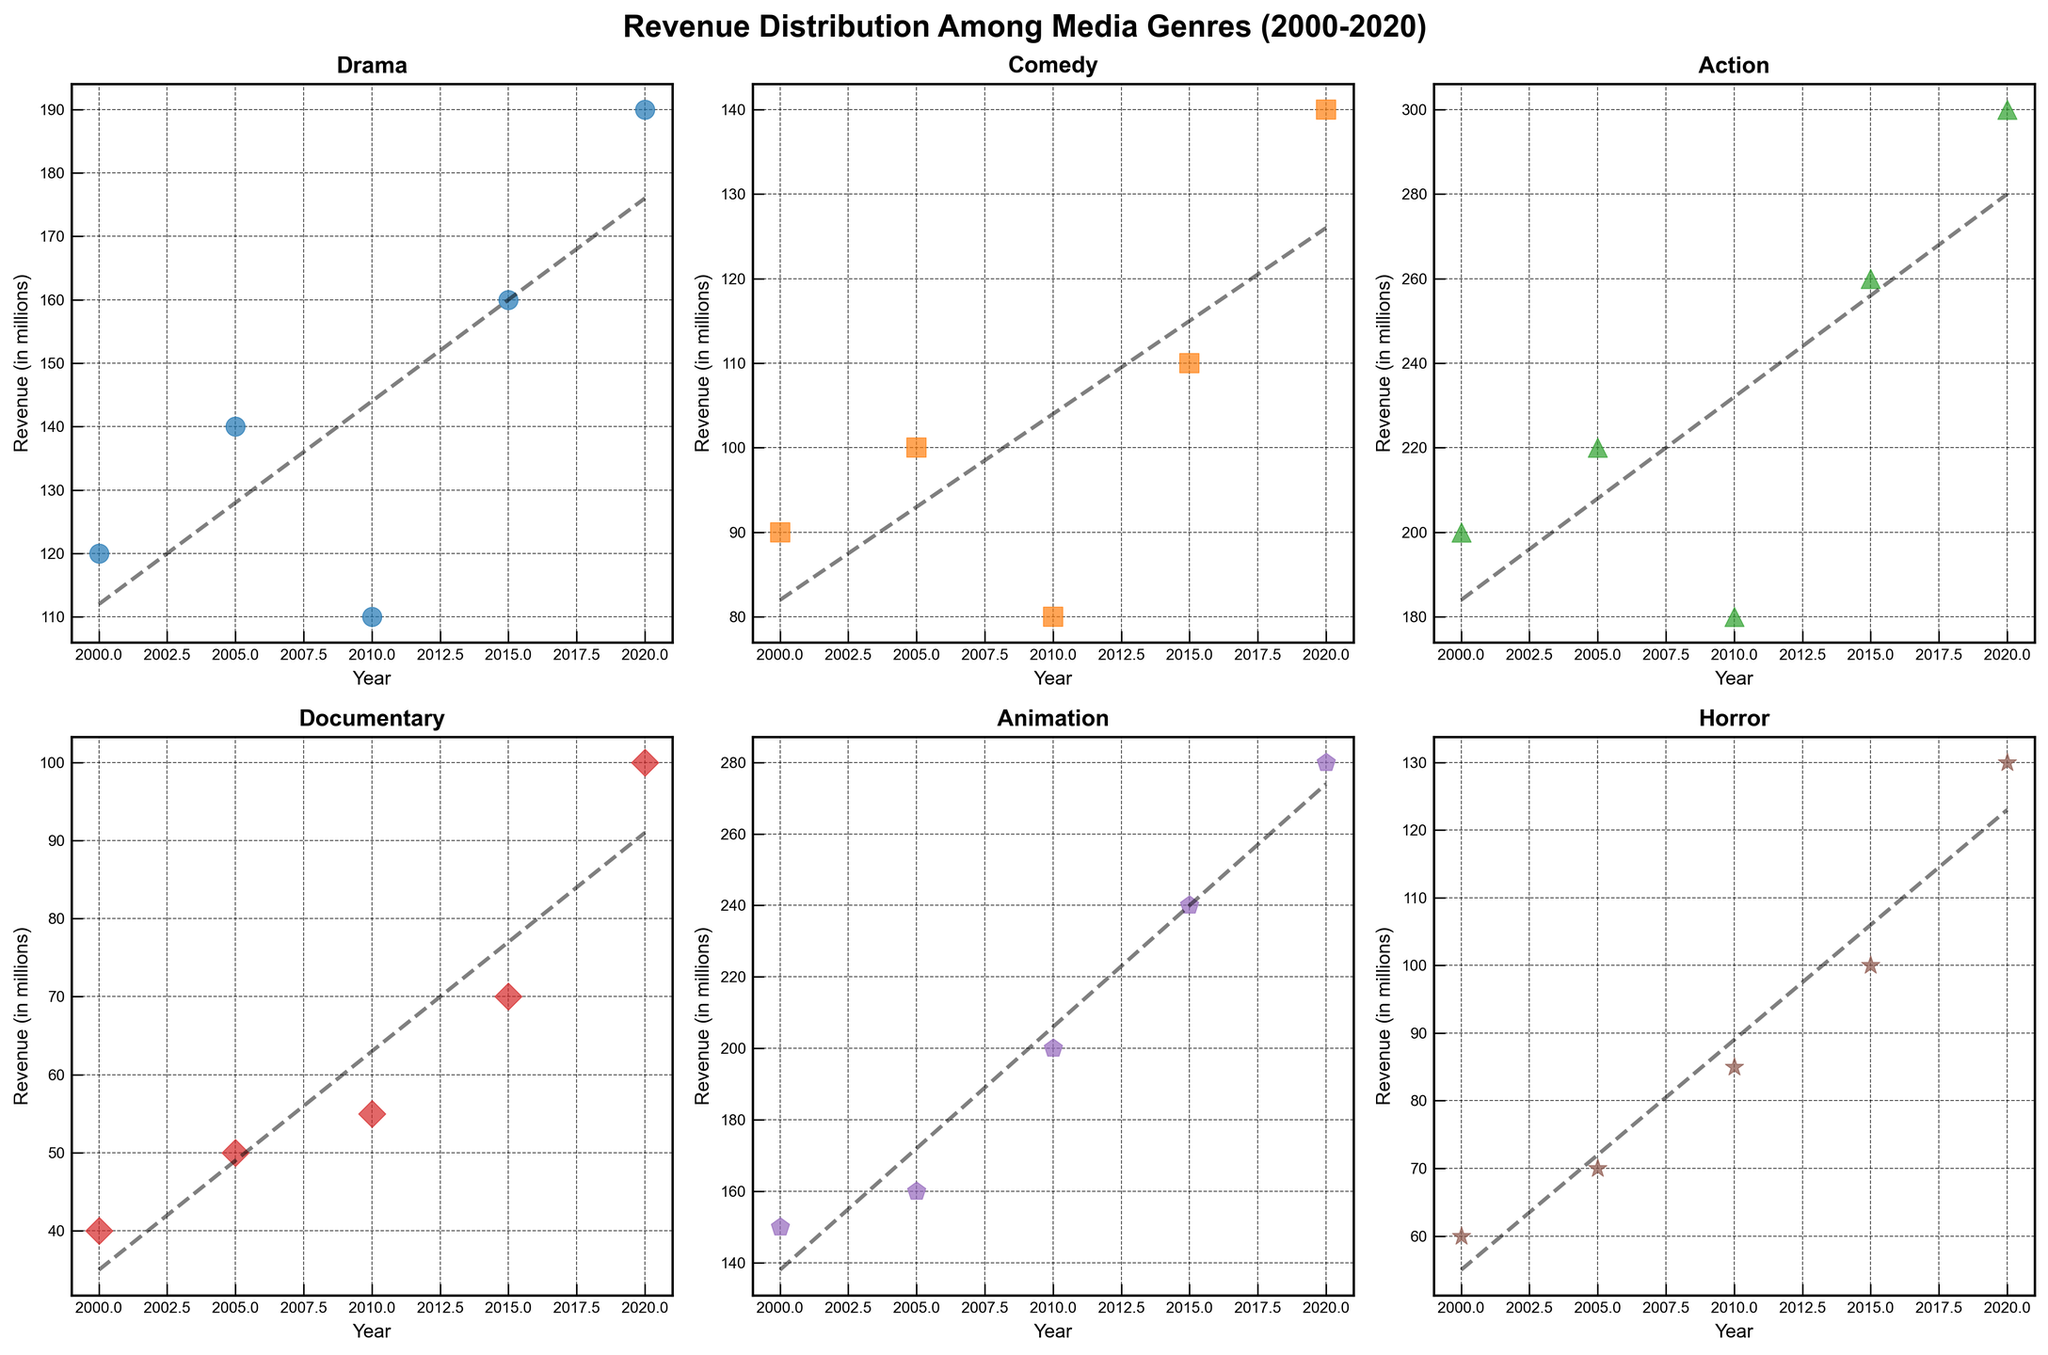Which genre had the highest revenue in 2020? Look at the plots for each genre and check the revenue value for the year 2020. Action had the highest value of 300 million.
Answer: Action What's the trend of revenue for Drama from 2000 to 2020? Observe the scatter plot for Drama and follow the trend line. The revenue shows an overall increasing trend with some fluctuations.
Answer: Increasing In 2010, which genre had the lowest revenue? Compare the 2010 revenue data points across all genres. Documentary had the lowest value at 55 million.
Answer: Documentary How did revenue for Animation change from 2000 to 2020? Check the revenue points for Animation in the years 2000 and 2020. Revenue increased from 150 million to 280 million.
Answer: Increased Which genre displayed the most consistent revenue growth from 2000 to 2020? Analyze the scatter plots for all genres and observe the trend lines. Documentary shows the most consistent growth trend.
Answer: Documentary By how much did Comedy revenue increase from 2000 to 2020? Subtract the 2000 value from the 2020 value for Comedy. 140 million - 90 million = 50 million.
Answer: 50 million Compare the revenue trend of Action and Drama. Which one had more fluctuations between 2000 and 2020? Observe the scatter plots and trend lines. Drama had more fluctuations compared to Action.
Answer: Drama Between 2000 and 2010, which genre showed a decline in revenue? Look at the plots between these years. Both Drama and Action showed a decline during this period.
Answer: Drama and Action How does the revenue distribution of Horror compare to that of Comedy over the 20 years? Compare the scatter plots and trend lines for Horror and Comedy. Both show an upward trend, but Horror grows more consistently.
Answer: Horror more consistent Which year did Documentary see the highest increase in revenue? Compare the year-to-year increments in the Documentary plot. The highest increase was from 2015 to 2020, which saw a 30 million increase.
Answer: 2015-2020 